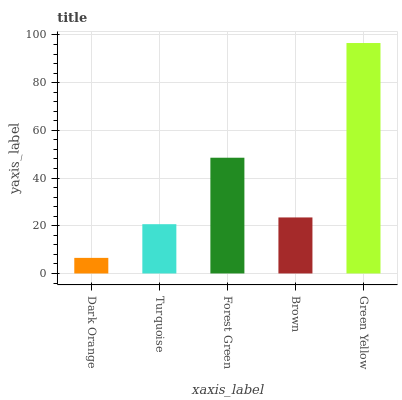Is Turquoise the minimum?
Answer yes or no. No. Is Turquoise the maximum?
Answer yes or no. No. Is Turquoise greater than Dark Orange?
Answer yes or no. Yes. Is Dark Orange less than Turquoise?
Answer yes or no. Yes. Is Dark Orange greater than Turquoise?
Answer yes or no. No. Is Turquoise less than Dark Orange?
Answer yes or no. No. Is Brown the high median?
Answer yes or no. Yes. Is Brown the low median?
Answer yes or no. Yes. Is Dark Orange the high median?
Answer yes or no. No. Is Green Yellow the low median?
Answer yes or no. No. 